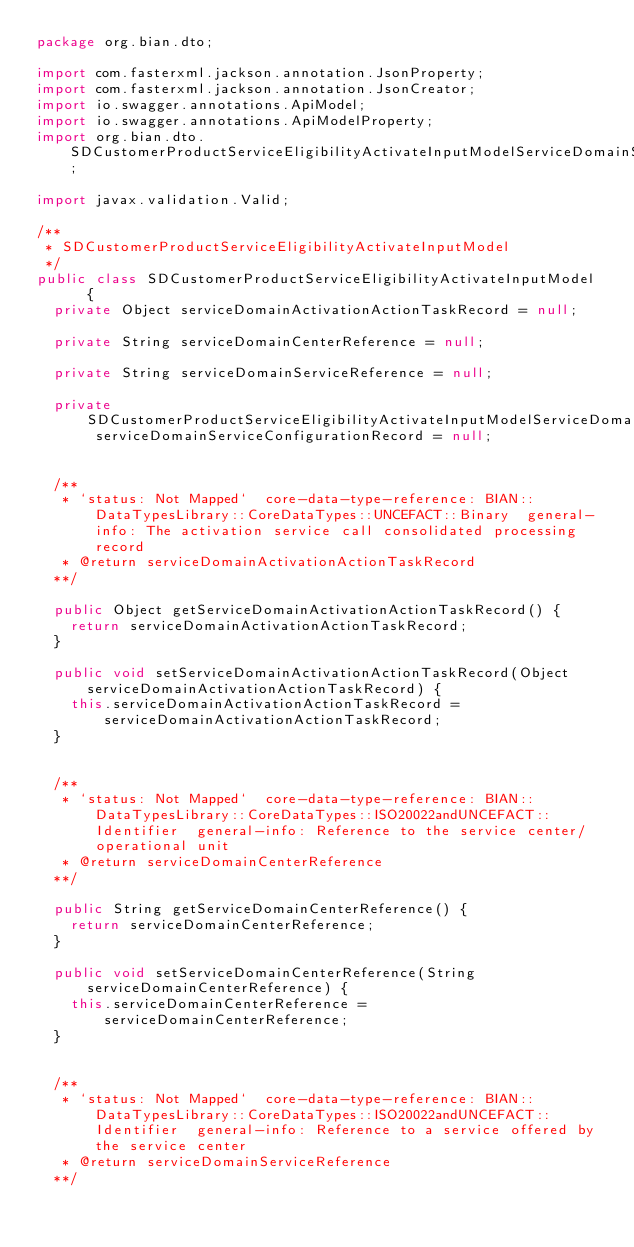Convert code to text. <code><loc_0><loc_0><loc_500><loc_500><_Java_>package org.bian.dto;

import com.fasterxml.jackson.annotation.JsonProperty;
import com.fasterxml.jackson.annotation.JsonCreator;
import io.swagger.annotations.ApiModel;
import io.swagger.annotations.ApiModelProperty;
import org.bian.dto.SDCustomerProductServiceEligibilityActivateInputModelServiceDomainServiceConfigurationRecord;

import javax.validation.Valid;
  
/**
 * SDCustomerProductServiceEligibilityActivateInputModel
 */
public class SDCustomerProductServiceEligibilityActivateInputModel   {
  private Object serviceDomainActivationActionTaskRecord = null;

  private String serviceDomainCenterReference = null;

  private String serviceDomainServiceReference = null;

  private SDCustomerProductServiceEligibilityActivateInputModelServiceDomainServiceConfigurationRecord serviceDomainServiceConfigurationRecord = null;


  /**
   * `status: Not Mapped`  core-data-type-reference: BIAN::DataTypesLibrary::CoreDataTypes::UNCEFACT::Binary  general-info: The activation service call consolidated processing record 
   * @return serviceDomainActivationActionTaskRecord
  **/

  public Object getServiceDomainActivationActionTaskRecord() {
    return serviceDomainActivationActionTaskRecord;
  }

  public void setServiceDomainActivationActionTaskRecord(Object serviceDomainActivationActionTaskRecord) {
    this.serviceDomainActivationActionTaskRecord = serviceDomainActivationActionTaskRecord;
  }


  /**
   * `status: Not Mapped`  core-data-type-reference: BIAN::DataTypesLibrary::CoreDataTypes::ISO20022andUNCEFACT::Identifier  general-info: Reference to the service center/operational unit 
   * @return serviceDomainCenterReference
  **/

  public String getServiceDomainCenterReference() {
    return serviceDomainCenterReference;
  }

  public void setServiceDomainCenterReference(String serviceDomainCenterReference) {
    this.serviceDomainCenterReference = serviceDomainCenterReference;
  }


  /**
   * `status: Not Mapped`  core-data-type-reference: BIAN::DataTypesLibrary::CoreDataTypes::ISO20022andUNCEFACT::Identifier  general-info: Reference to a service offered by the service center 
   * @return serviceDomainServiceReference
  **/
</code> 